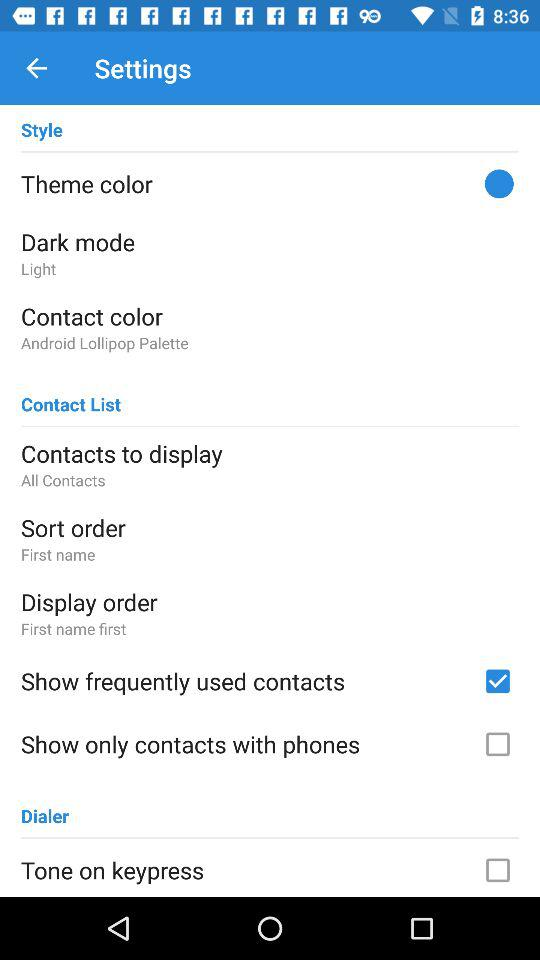Is "Contact List" checked or unchecked?
When the provided information is insufficient, respond with <no answer>. <no answer> 